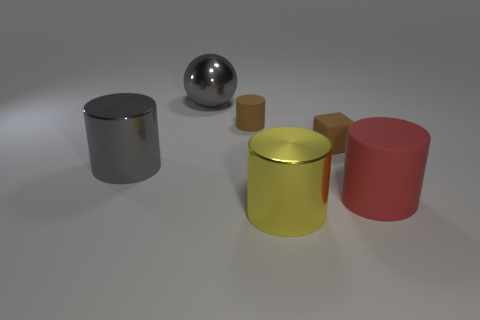Are there the same number of tiny rubber cylinders in front of the big yellow cylinder and yellow shiny objects?
Keep it short and to the point. No. Is there anything else that has the same material as the red cylinder?
Give a very brief answer. Yes. Is the small brown thing that is to the right of the big yellow object made of the same material as the red cylinder?
Offer a terse response. Yes. Is the number of large spheres that are to the right of the tiny matte block less than the number of big brown rubber spheres?
Offer a very short reply. No. How many shiny things are either large yellow cylinders or small gray cubes?
Provide a short and direct response. 1. Is the large ball the same color as the tiny rubber block?
Give a very brief answer. No. Is there anything else of the same color as the block?
Offer a terse response. Yes. There is a thing in front of the big red thing; is it the same shape as the big object to the right of the block?
Provide a succinct answer. Yes. How many things are either gray shiny things or large metallic objects in front of the red object?
Offer a very short reply. 3. What number of other things are there of the same size as the brown matte cylinder?
Offer a terse response. 1. 